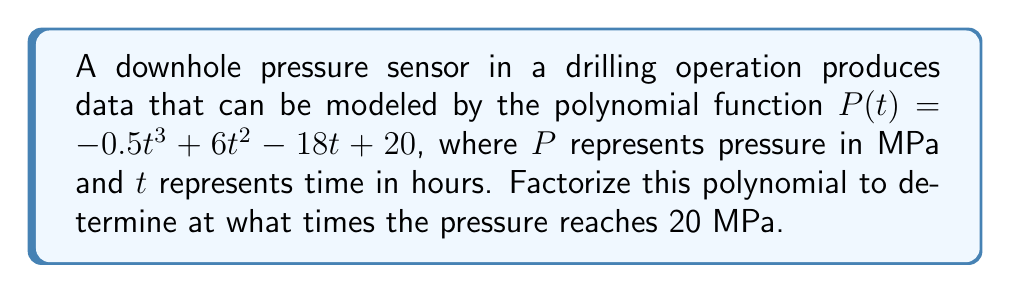Teach me how to tackle this problem. To solve this problem, we need to follow these steps:

1) First, we set up the equation:
   $P(t) = 20$
   $-0.5t^3 + 6t^2 - 18t + 20 = 20$

2) Simplify by subtracting 20 from both sides:
   $-0.5t^3 + 6t^2 - 18t = 0$

3) Factor out the greatest common factor:
   $-0.5(t^3 - 12t^2 + 36t) = 0$

4) Factor the expression inside the parentheses:
   $-0.5(t(t^2 - 12t + 36)) = 0$
   $-0.5(t(t - 6)(t - 6)) = 0$

5) Set each factor to zero and solve for t:
   $-0.5 = 0$ (not possible, as -0.5 is a constant)
   $t = 0$
   $t - 6 = 0$, so $t = 6$

6) The factor $(t - 6)$ appears twice, indicating a double root at $t = 6$.

Therefore, the pressure reaches 20 MPa at $t = 0$ and $t = 6$ hours, with $t = 6$ being a double root.
Answer: $t = 0$ and $t = 6$ (double root) 